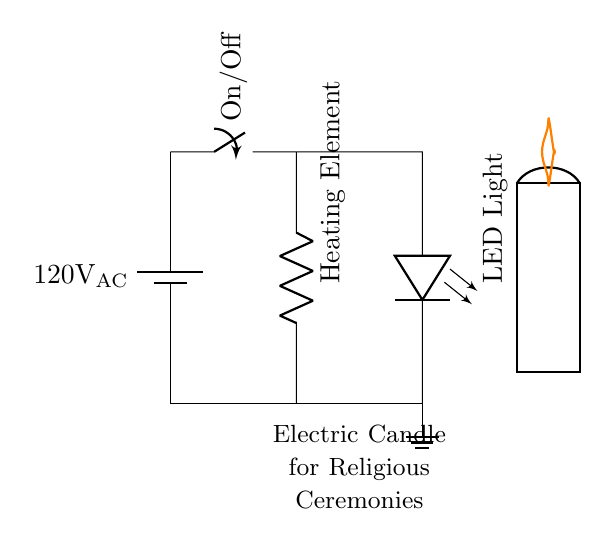What is the voltage of this circuit? The voltage is 120V, which is shown next to the battery symbol indicating the power source.
Answer: 120V What type of switch is used in this circuit? The switch is an On/Off type, indicated by the label next to the switch symbol.
Answer: On/Off How many main components are in this circuit? There are four main components: a battery, a switch, a heating element, and an LED light.
Answer: Four What does the LED represent in this circuit? The LED represents the light aspect of the electric candle, denoted by the LED symbol in the diagram.
Answer: Light What is the purpose of the resistor in this circuit? The resistor represents the heating element, which is essential for simulating the candle's flame.
Answer: Heating Element Which component controls the flow of electricity? The switch controls the flow, allowing it to be turned on or off as indicated in the circuit.
Answer: Switch What does the ground symbol indicate in this circuit? The ground symbol indicates the reference point for the voltage in the circuit and is often used for safety.
Answer: Ground 